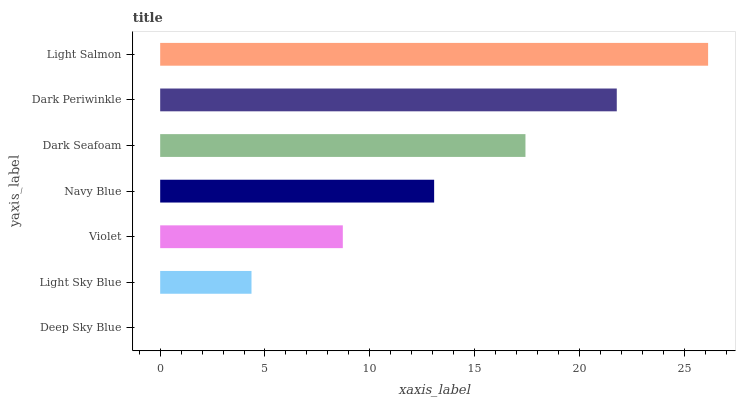Is Deep Sky Blue the minimum?
Answer yes or no. Yes. Is Light Salmon the maximum?
Answer yes or no. Yes. Is Light Sky Blue the minimum?
Answer yes or no. No. Is Light Sky Blue the maximum?
Answer yes or no. No. Is Light Sky Blue greater than Deep Sky Blue?
Answer yes or no. Yes. Is Deep Sky Blue less than Light Sky Blue?
Answer yes or no. Yes. Is Deep Sky Blue greater than Light Sky Blue?
Answer yes or no. No. Is Light Sky Blue less than Deep Sky Blue?
Answer yes or no. No. Is Navy Blue the high median?
Answer yes or no. Yes. Is Navy Blue the low median?
Answer yes or no. Yes. Is Deep Sky Blue the high median?
Answer yes or no. No. Is Light Salmon the low median?
Answer yes or no. No. 